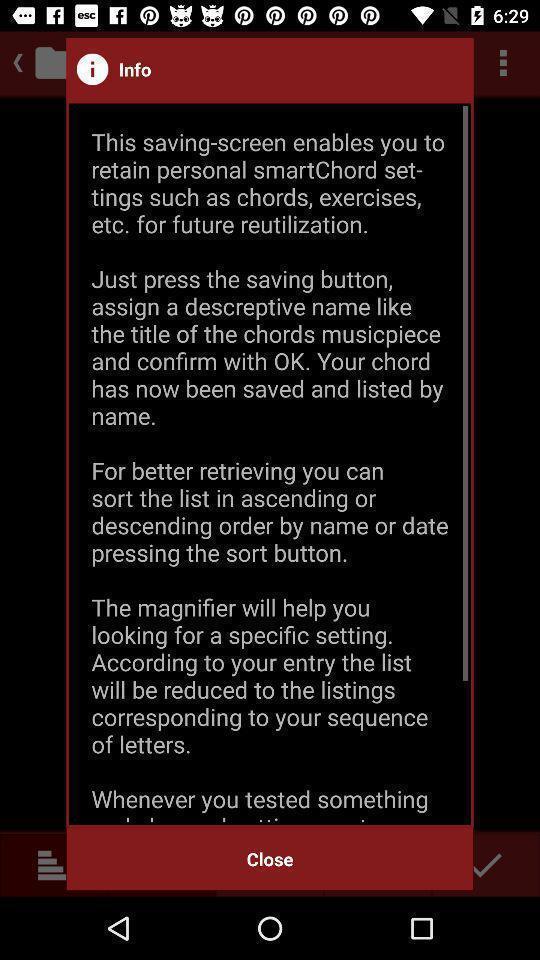Explain the elements present in this screenshot. Popup showing information. 